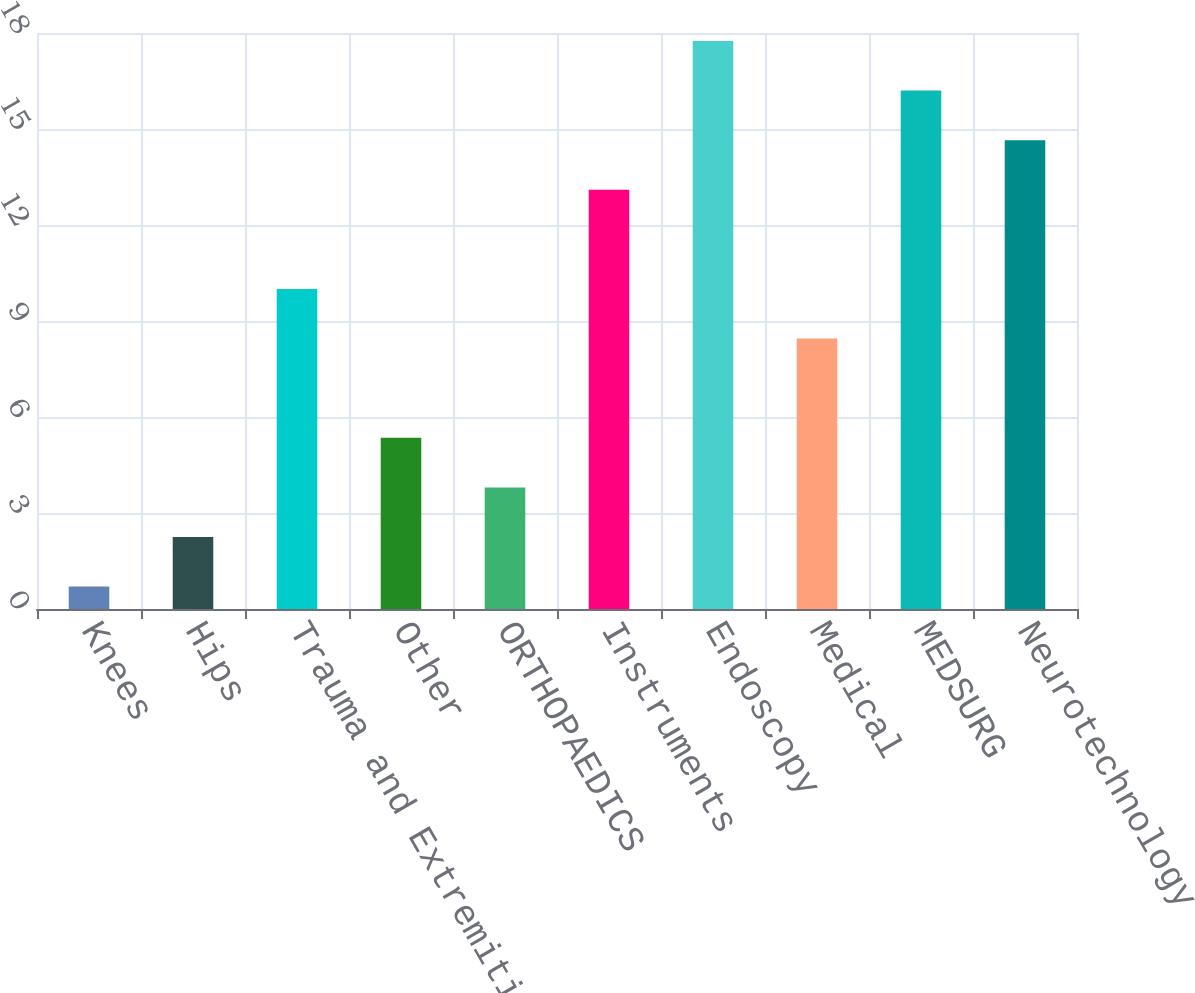Convert chart to OTSL. <chart><loc_0><loc_0><loc_500><loc_500><bar_chart><fcel>Knees<fcel>Hips<fcel>Trauma and Extremities<fcel>Other<fcel>ORTHOPAEDICS<fcel>Instruments<fcel>Endoscopy<fcel>Medical<fcel>MEDSURG<fcel>Neurotechnology<nl><fcel>0.7<fcel>2.25<fcel>10<fcel>5.35<fcel>3.8<fcel>13.1<fcel>17.75<fcel>8.45<fcel>16.2<fcel>14.65<nl></chart> 